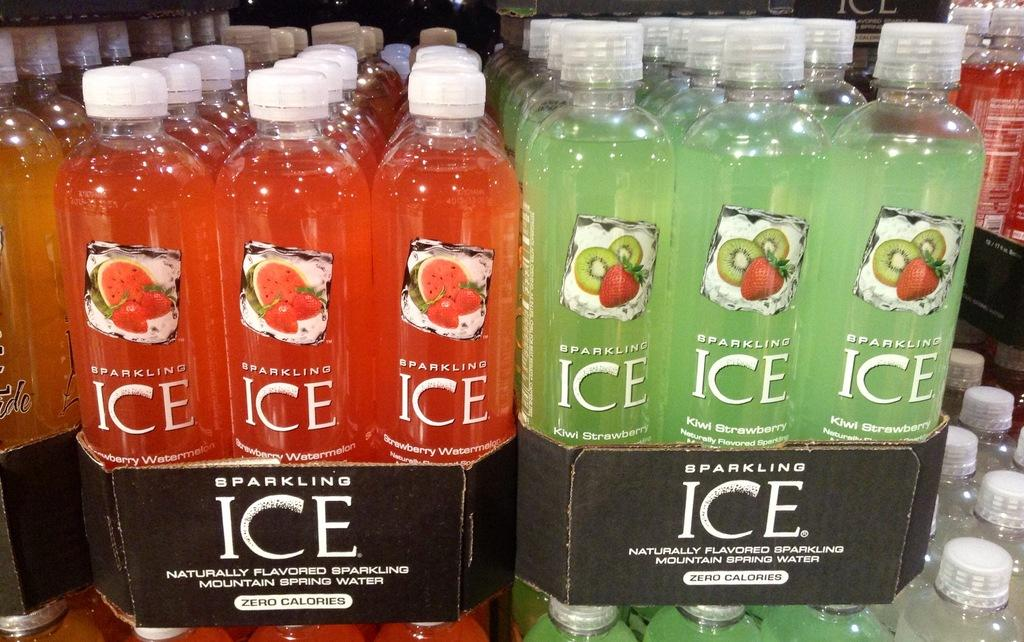Provide a one-sentence caption for the provided image. Packs of Sparkling Ice bottled water with zero calories. 